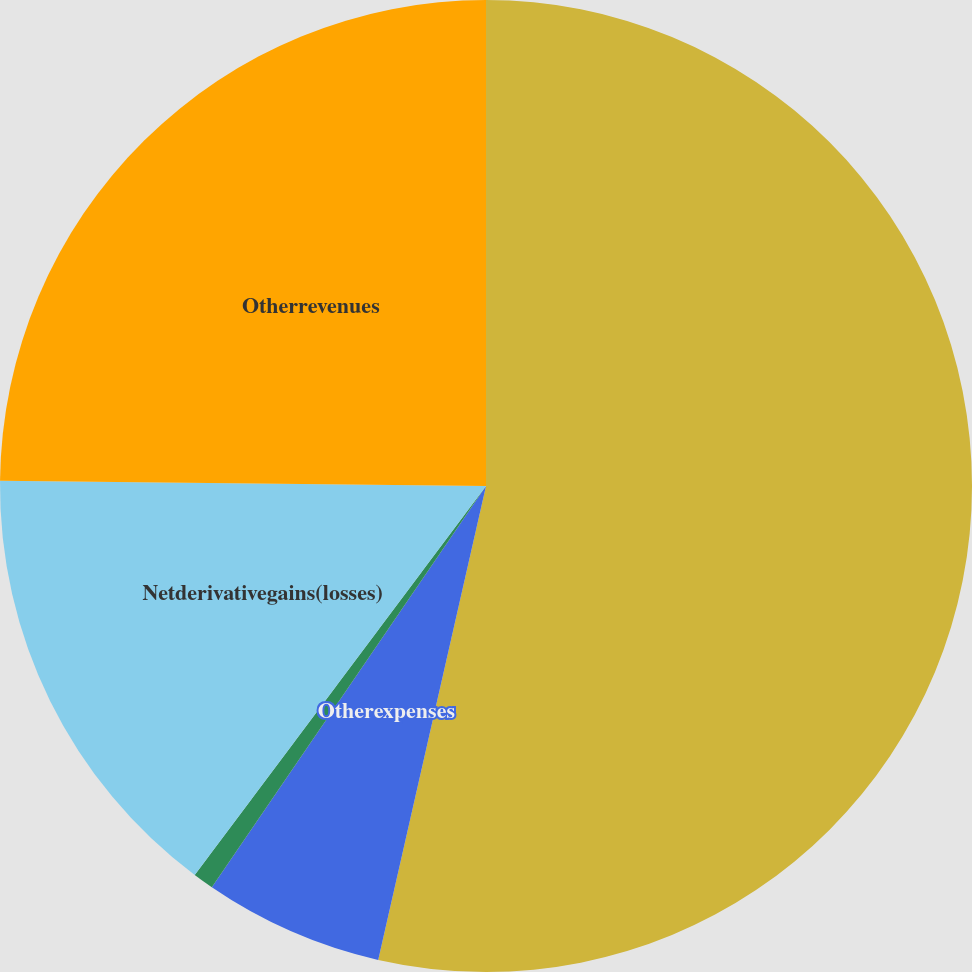Convert chart to OTSL. <chart><loc_0><loc_0><loc_500><loc_500><pie_chart><ecel><fcel>Otherexpenses<fcel>Netinvestmentincome<fcel>Netderivativegains(losses)<fcel>Otherrevenues<nl><fcel>53.56%<fcel>5.98%<fcel>0.69%<fcel>14.94%<fcel>24.83%<nl></chart> 